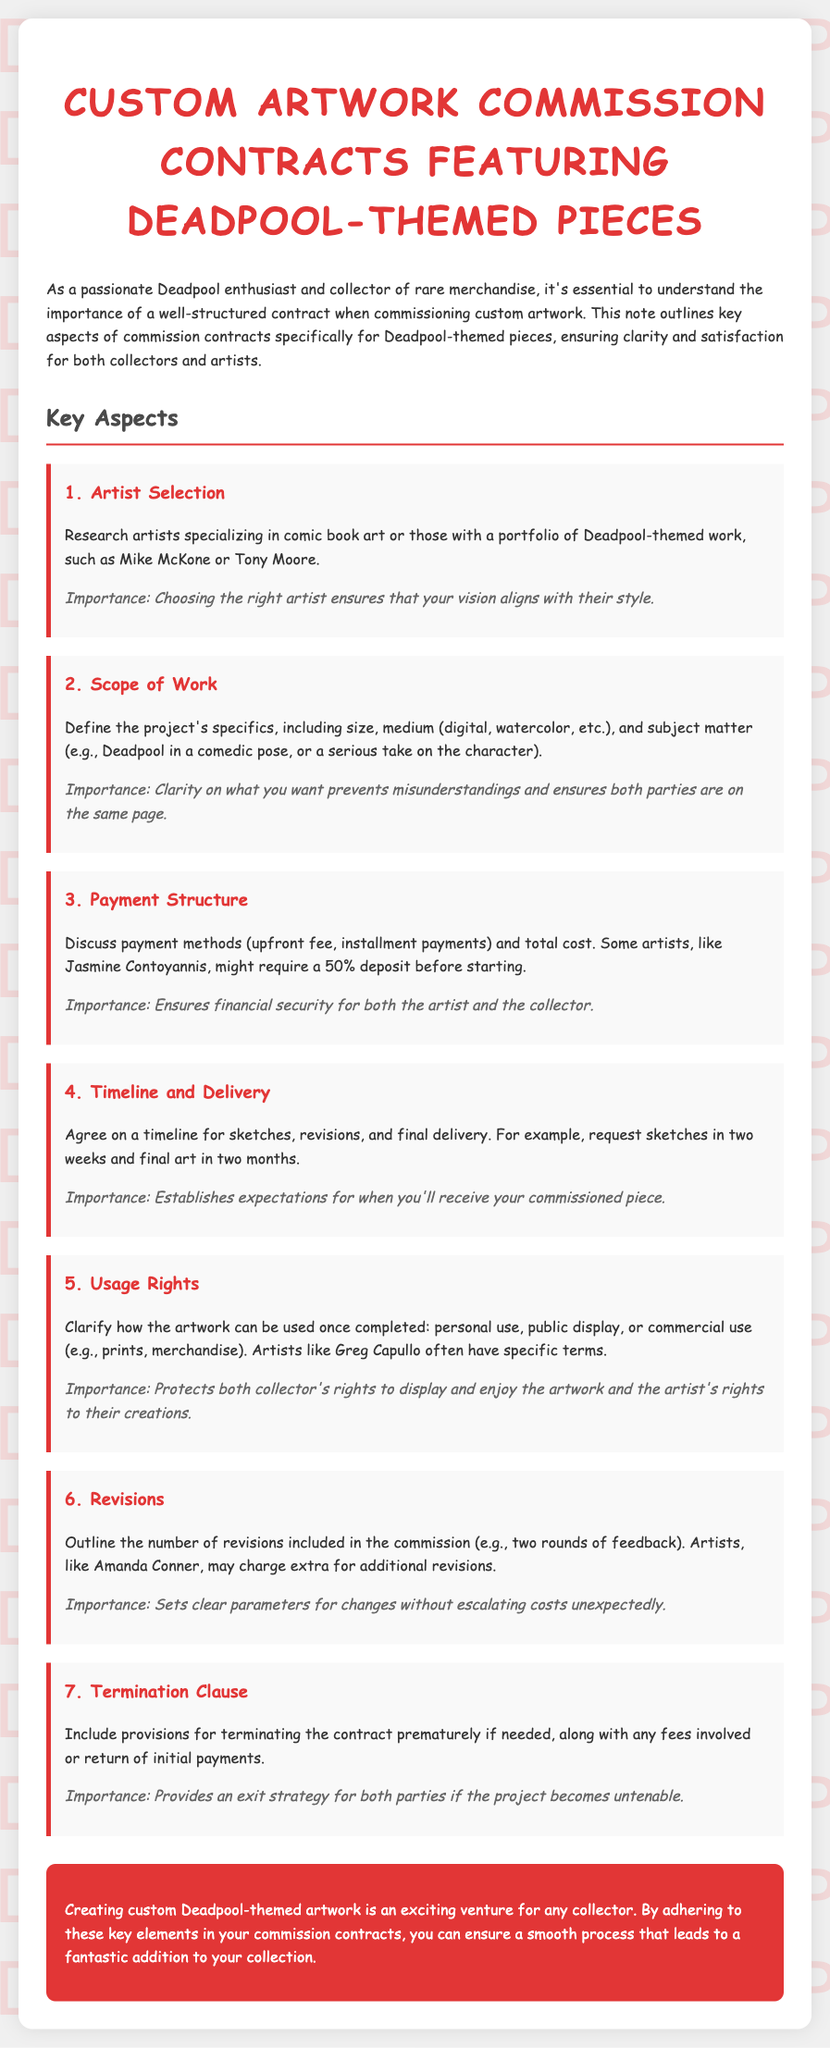What is the title of the document? The title appears at the top of the rendered document, indicating the content focuses on custom artwork contracts featuring Deadpool pieces.
Answer: Custom Artwork Commission Contracts Featuring Deadpool-themed Pieces Who is one of the artists mentioned for selection? The document discusses artist selection and mentions specific artists with Deadpool-themed work, highlighting their experience in comic book art.
Answer: Mike McKone What is discussed regarding payment structure? The section outlines payment methods and some artists' deposit requirements, ensuring financial security for both parties involved.
Answer: 50% deposit How many revisions are included in the commission? The document specifies the outline for revisions in the commission agreement, particularly noting the number included in the contract.
Answer: Two rounds What should be clarified regarding usage rights? This aspect of the contract indicates how the artwork can be utilized once it is completed, protecting both the collector's and artist’s rights.
Answer: Personal use What is the importance of defining the scope of work? The document emphasizes the necessity of having clarity on project specifics to prevent misunderstandings between artists and collectors.
Answer: Prevents misunderstandings What does the termination clause provide? The document indicates the need for provisions that address contract termination and associated fees, illustrating considerations for both parties.
Answer: Exit strategy What is the timeframe suggested for final delivery? The document mentions an example of how long it might take to have the final art ready for the collector, aiding in setting expectations.
Answer: Two months 